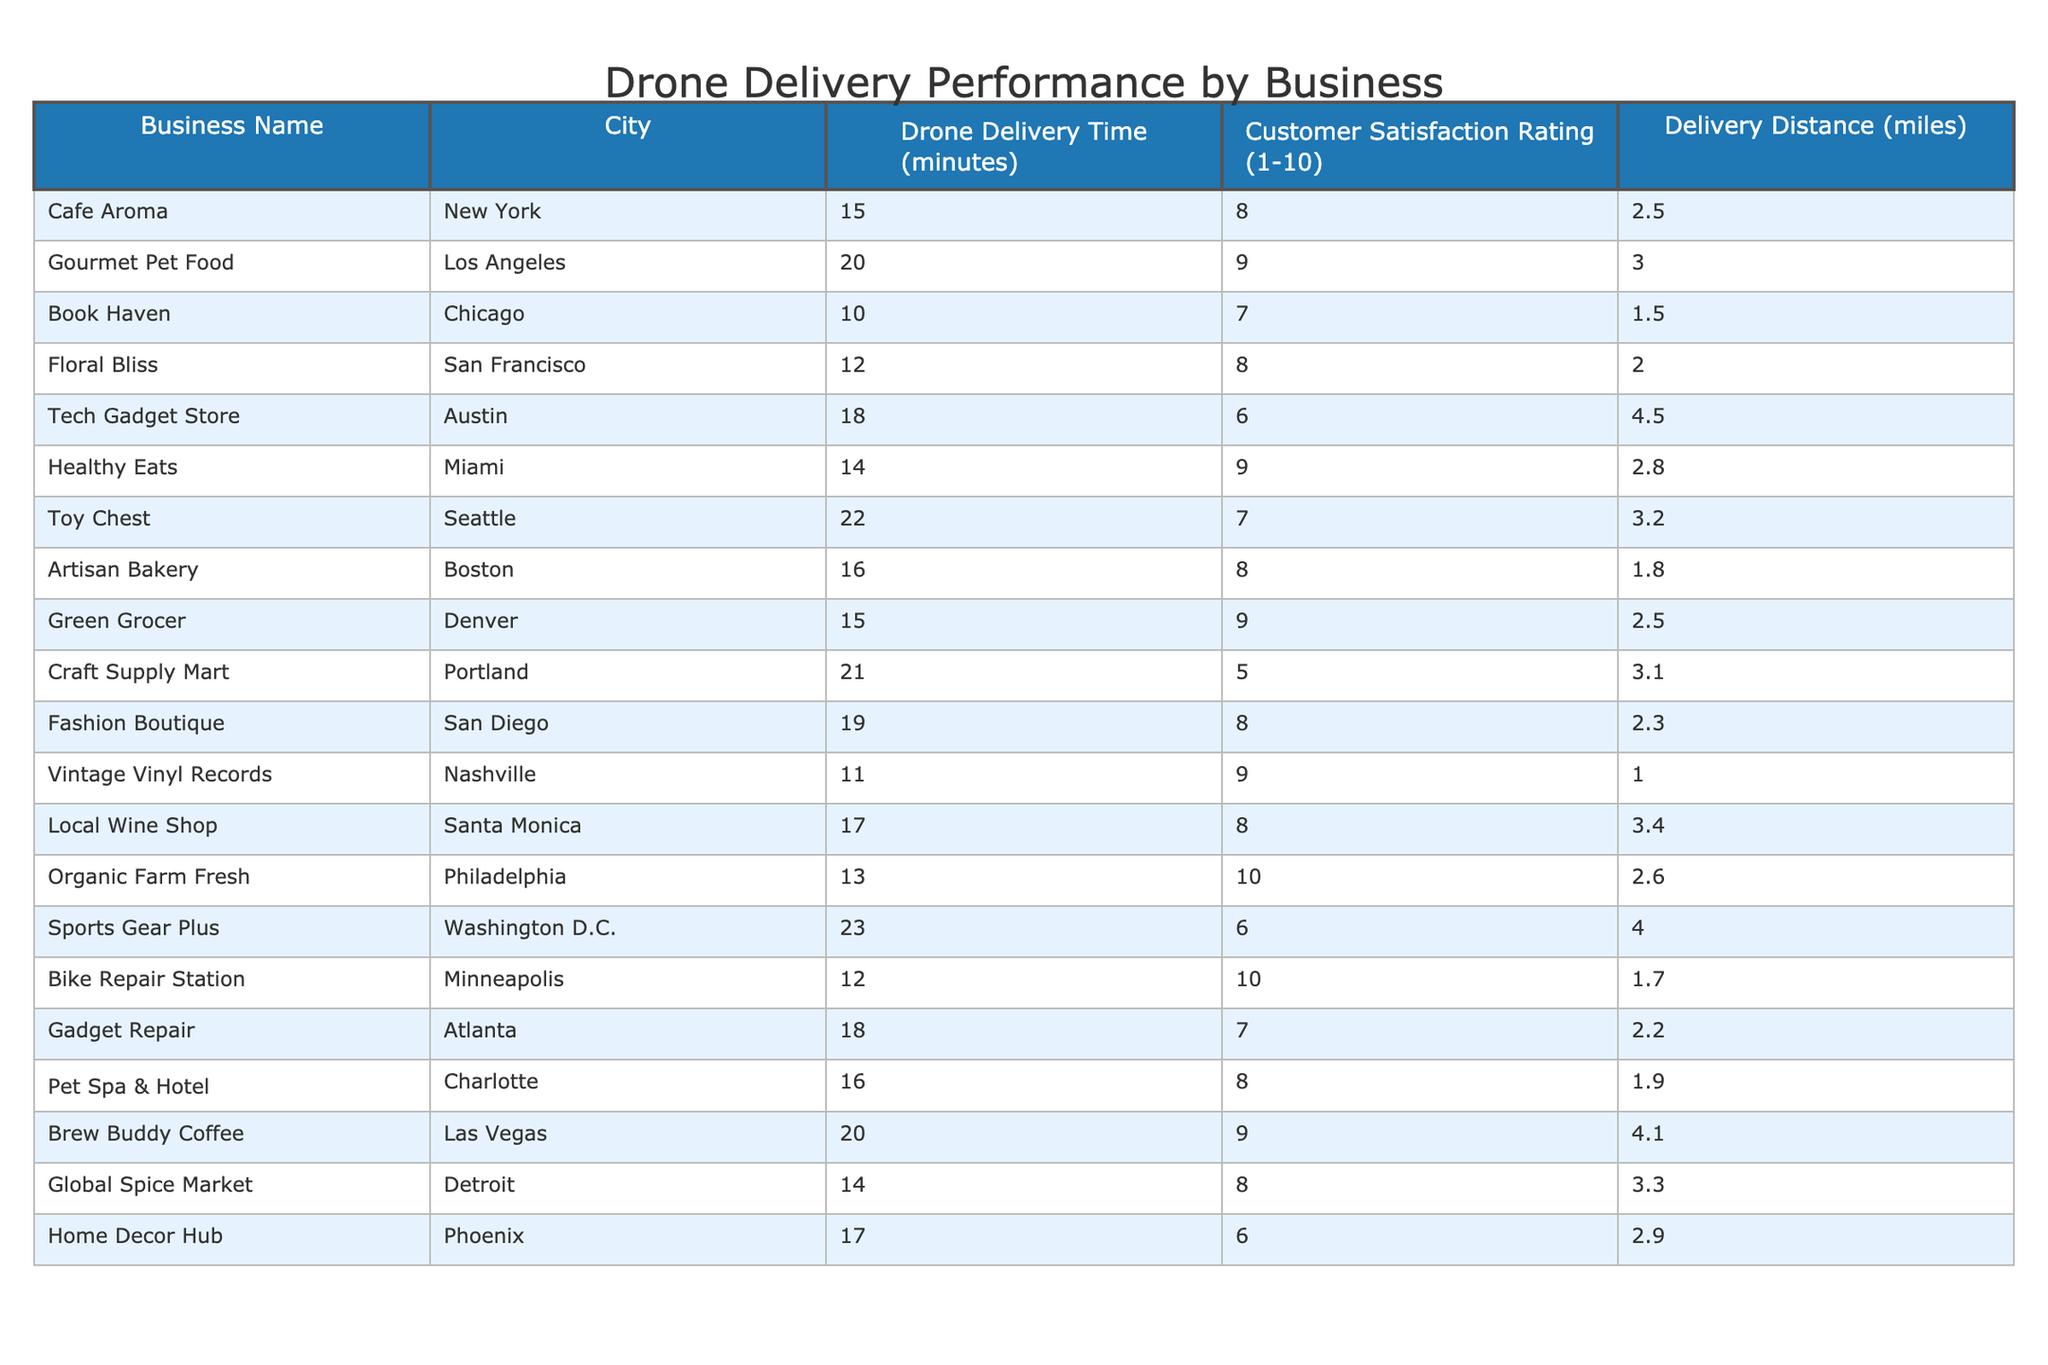What is the customer satisfaction rating for Cafe Aroma? The table shows the customer satisfaction rating for Cafe Aroma is 8.
Answer: 8 Which business has the shortest delivery time? By comparing the delivery times in the table, Book Haven has the shortest delivery time of 10 minutes.
Answer: 10 minutes What is the average customer satisfaction rating for businesses with delivery times under 15 minutes? The businesses under 15 minutes are: Cafe Aroma (8), Book Haven (7), Floral Bliss (8), Healthy Eats (9), and Bike Repair Station (10). Their ratings total 42, and there are 5 businesses, so the average is 42/5 = 8.4.
Answer: 8.4 True or False: Sports Gear Plus has a higher delivery time than Gadget Repair. Sports Gear Plus has a delivery time of 23 minutes, while Gadget Repair has 18 minutes. Since 23 is greater than 18, the statement is true.
Answer: True Which city has the highest customer satisfaction rating for drone deliveries? Comparing the ratings for each city, Organic Farm Fresh in Philadelphia has the highest rating of 10.
Answer: Philadelphia How many businesses have a customer satisfaction rating above 8? The businesses with a rating above 8 are Gourmet Pet Food (9), Healthy Eats (9), Vintage Vinyl Records (9), Organic Farm Fresh (10), and Brew Buddy Coffee (9). This gives a total of 5 businesses.
Answer: 5 What is the difference in delivery time between the fastest and slowest drone deliveries? The fastest delivery time is 10 minutes (Book Haven), and the slowest is 23 minutes (Sports Gear Plus). The difference is 23 - 10 = 13 minutes.
Answer: 13 minutes Which business has the longest delivery distance and what is that distance? The business with the longest delivery distance is Tech Gadget Store at 4.5 miles.
Answer: 4.5 miles What is the average delivery time for businesses located in New York and California? For New York (Cafe Aroma: 15 minutes) and California (Gourmet Pet Food: 20 minutes, Local Wine Shop: 17 minutes), the total delivery time is 15 + 20 + 17 = 52 minutes. There are 3 businesses, so the average is 52/3 = 17.33 minutes.
Answer: 17.33 minutes Is there any business with a customer satisfaction rating of 6? Checking the table, there are two businesses with a rating of 6: Tech Gadget Store and Home Decor Hub. Thus, the answer is yes.
Answer: Yes 